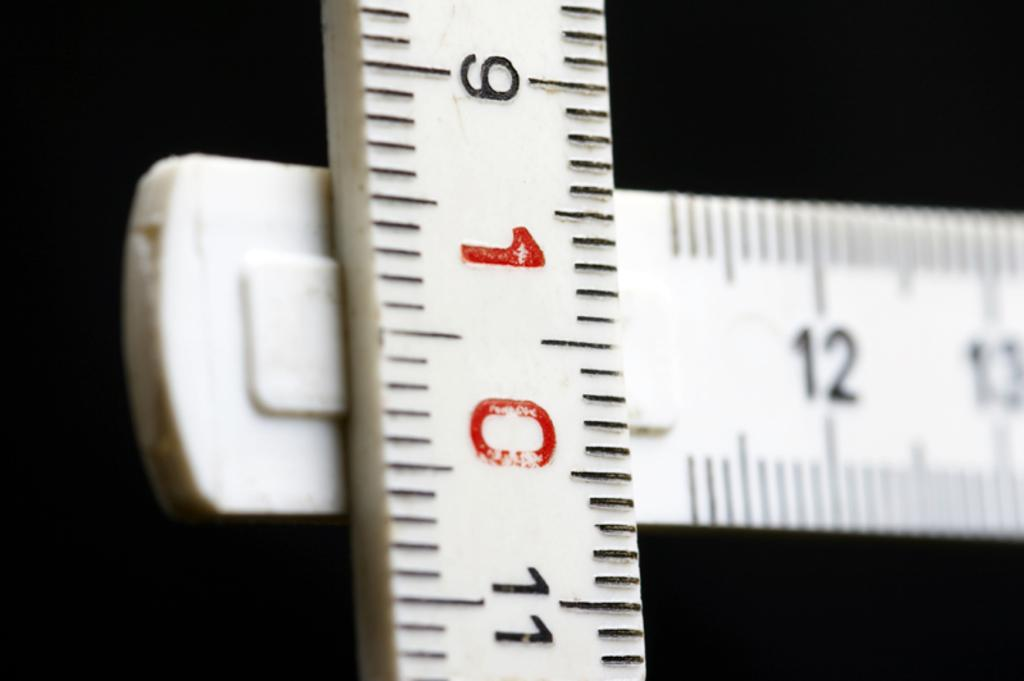<image>
Write a terse but informative summary of the picture. A ruler lies across another ruler, and the number 10 is in red. 